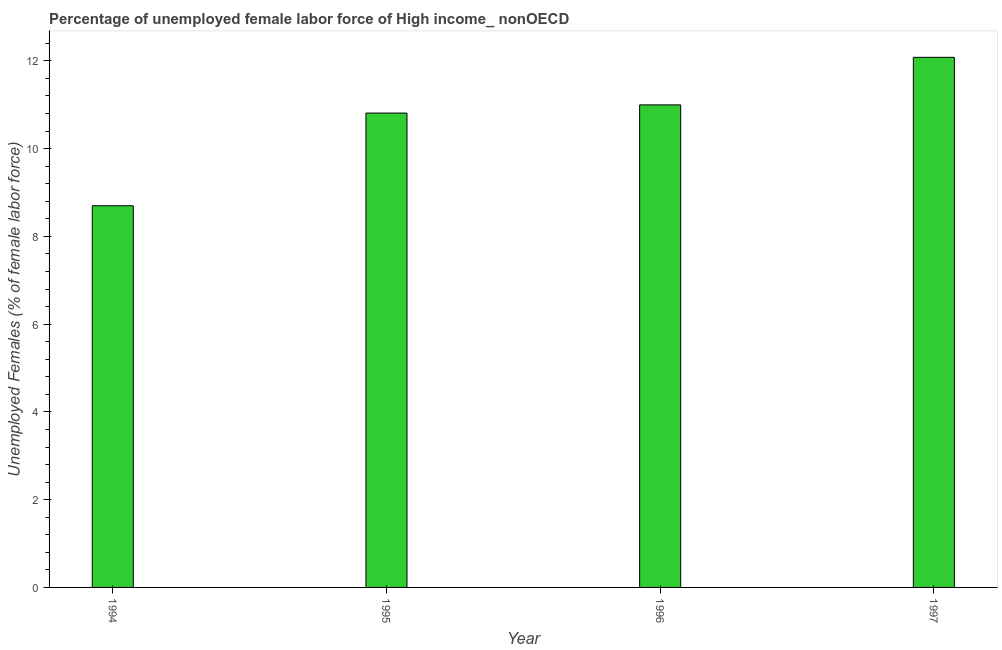What is the title of the graph?
Offer a very short reply. Percentage of unemployed female labor force of High income_ nonOECD. What is the label or title of the X-axis?
Your answer should be very brief. Year. What is the label or title of the Y-axis?
Provide a short and direct response. Unemployed Females (% of female labor force). What is the total unemployed female labour force in 1996?
Ensure brevity in your answer.  11. Across all years, what is the maximum total unemployed female labour force?
Give a very brief answer. 12.08. Across all years, what is the minimum total unemployed female labour force?
Offer a terse response. 8.7. In which year was the total unemployed female labour force maximum?
Provide a short and direct response. 1997. In which year was the total unemployed female labour force minimum?
Your response must be concise. 1994. What is the sum of the total unemployed female labour force?
Give a very brief answer. 42.58. What is the difference between the total unemployed female labour force in 1996 and 1997?
Provide a succinct answer. -1.08. What is the average total unemployed female labour force per year?
Your answer should be compact. 10.65. What is the median total unemployed female labour force?
Your answer should be very brief. 10.9. In how many years, is the total unemployed female labour force greater than 5.6 %?
Your answer should be compact. 4. Do a majority of the years between 1997 and 1996 (inclusive) have total unemployed female labour force greater than 6.4 %?
Give a very brief answer. No. What is the ratio of the total unemployed female labour force in 1996 to that in 1997?
Provide a short and direct response. 0.91. Is the total unemployed female labour force in 1994 less than that in 1996?
Give a very brief answer. Yes. What is the difference between the highest and the second highest total unemployed female labour force?
Keep it short and to the point. 1.08. Is the sum of the total unemployed female labour force in 1996 and 1997 greater than the maximum total unemployed female labour force across all years?
Provide a short and direct response. Yes. What is the difference between the highest and the lowest total unemployed female labour force?
Keep it short and to the point. 3.38. In how many years, is the total unemployed female labour force greater than the average total unemployed female labour force taken over all years?
Offer a very short reply. 3. How many bars are there?
Make the answer very short. 4. Are all the bars in the graph horizontal?
Give a very brief answer. No. How many years are there in the graph?
Provide a short and direct response. 4. What is the difference between two consecutive major ticks on the Y-axis?
Keep it short and to the point. 2. What is the Unemployed Females (% of female labor force) of 1994?
Provide a short and direct response. 8.7. What is the Unemployed Females (% of female labor force) of 1995?
Provide a succinct answer. 10.81. What is the Unemployed Females (% of female labor force) in 1996?
Offer a very short reply. 11. What is the Unemployed Females (% of female labor force) of 1997?
Ensure brevity in your answer.  12.08. What is the difference between the Unemployed Females (% of female labor force) in 1994 and 1995?
Your answer should be compact. -2.11. What is the difference between the Unemployed Females (% of female labor force) in 1994 and 1996?
Offer a terse response. -2.3. What is the difference between the Unemployed Females (% of female labor force) in 1994 and 1997?
Provide a short and direct response. -3.38. What is the difference between the Unemployed Females (% of female labor force) in 1995 and 1996?
Provide a succinct answer. -0.19. What is the difference between the Unemployed Females (% of female labor force) in 1995 and 1997?
Provide a short and direct response. -1.27. What is the difference between the Unemployed Females (% of female labor force) in 1996 and 1997?
Give a very brief answer. -1.08. What is the ratio of the Unemployed Females (% of female labor force) in 1994 to that in 1995?
Provide a short and direct response. 0.81. What is the ratio of the Unemployed Females (% of female labor force) in 1994 to that in 1996?
Provide a short and direct response. 0.79. What is the ratio of the Unemployed Females (% of female labor force) in 1994 to that in 1997?
Provide a succinct answer. 0.72. What is the ratio of the Unemployed Females (% of female labor force) in 1995 to that in 1997?
Offer a very short reply. 0.9. What is the ratio of the Unemployed Females (% of female labor force) in 1996 to that in 1997?
Your response must be concise. 0.91. 